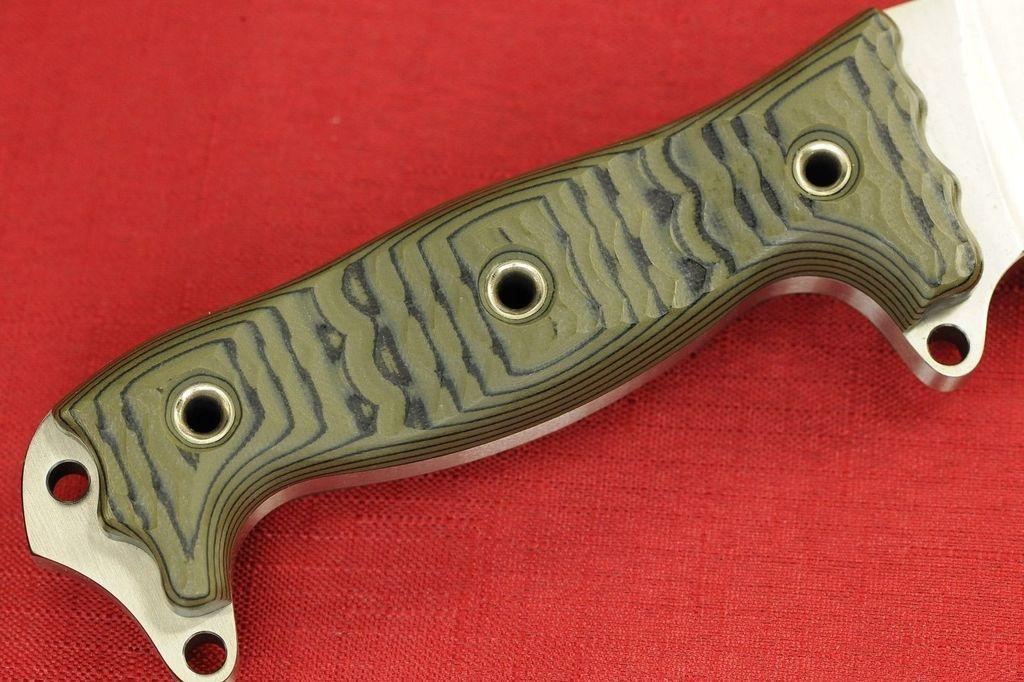What type of object is present on the red color cloth in the image? There is a metal knife on the red color cloth in the image. What type of drum can be seen being played by the clam in the image? There is no drum or clam present in the image; it only features a metal knife on a red color cloth. 